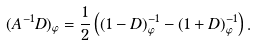<formula> <loc_0><loc_0><loc_500><loc_500>( A ^ { - 1 } D ) _ { \varphi } = \frac { 1 } { 2 } \left ( ( 1 - D ) _ { \varphi } ^ { - 1 } - ( 1 + D ) _ { \varphi } ^ { - 1 } \right ) .</formula> 